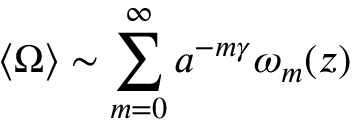<formula> <loc_0><loc_0><loc_500><loc_500>\langle \Omega \rangle \sim \sum _ { m = 0 } ^ { \infty } a ^ { - m \gamma } \omega _ { m } ( z )</formula> 